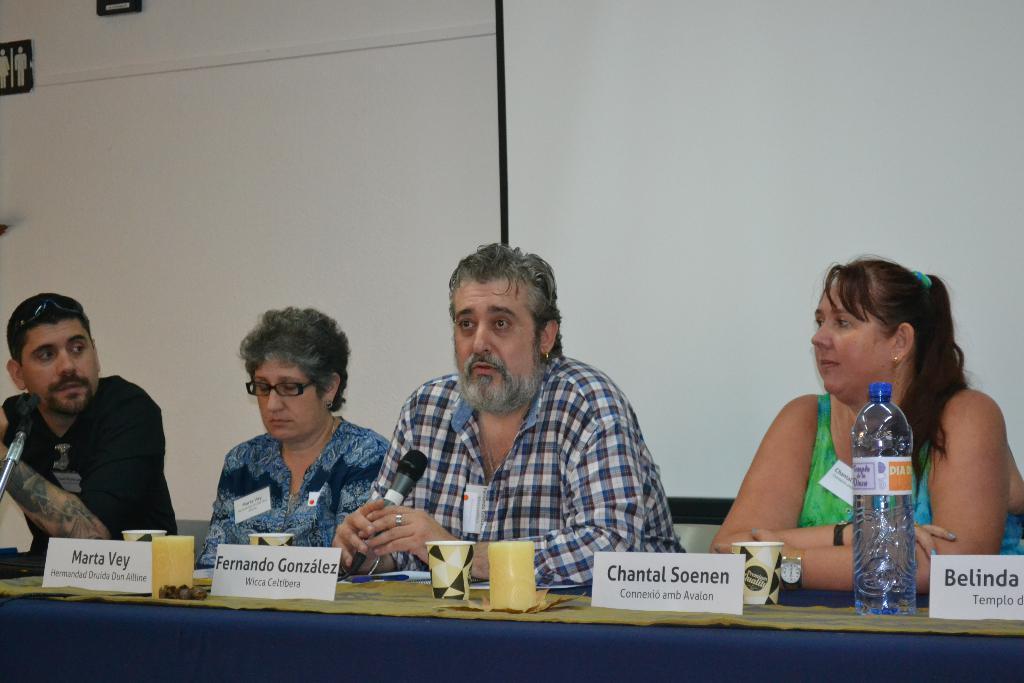How would you summarize this image in a sentence or two? In this image i can see 2 men and 2 women sitting in front of a table. On the table i can see few board, a water bottle, few cups. In the background i can see a wall and a banner. 